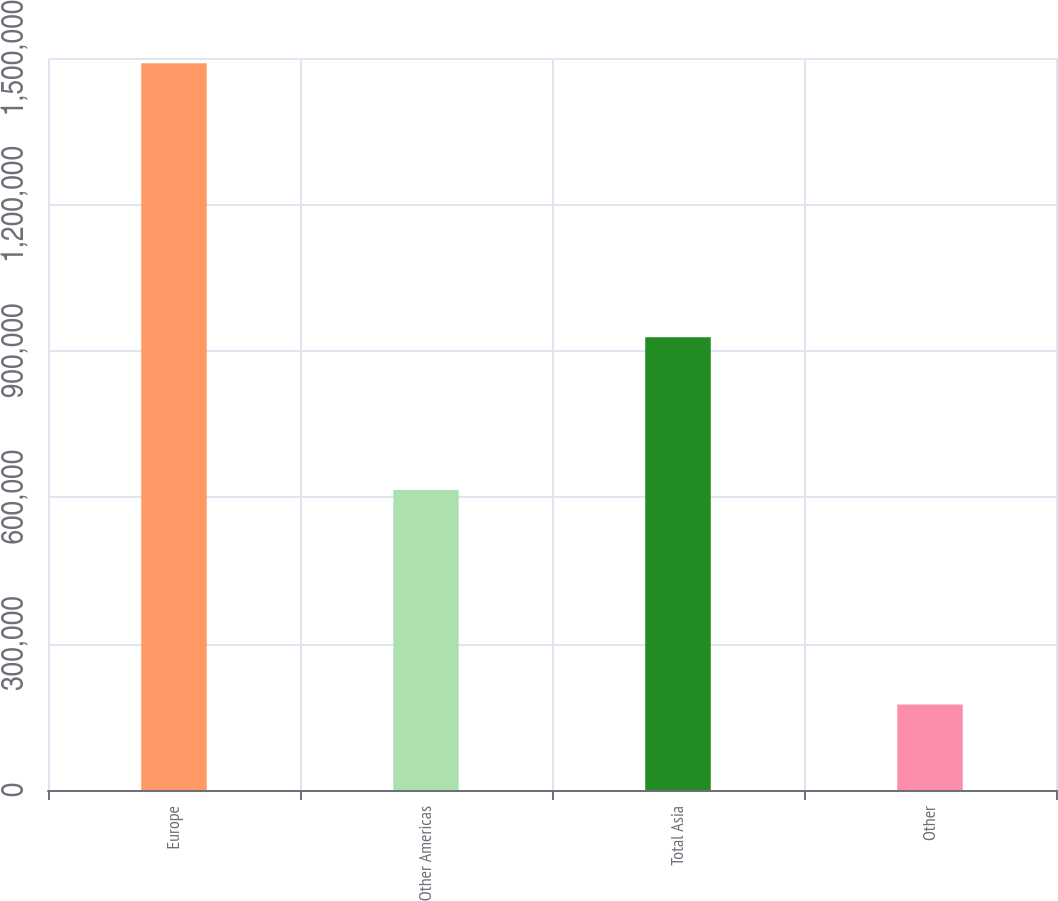Convert chart to OTSL. <chart><loc_0><loc_0><loc_500><loc_500><bar_chart><fcel>Europe<fcel>Other Americas<fcel>Total Asia<fcel>Other<nl><fcel>1.48932e+06<fcel>614769<fcel>927685<fcel>175141<nl></chart> 